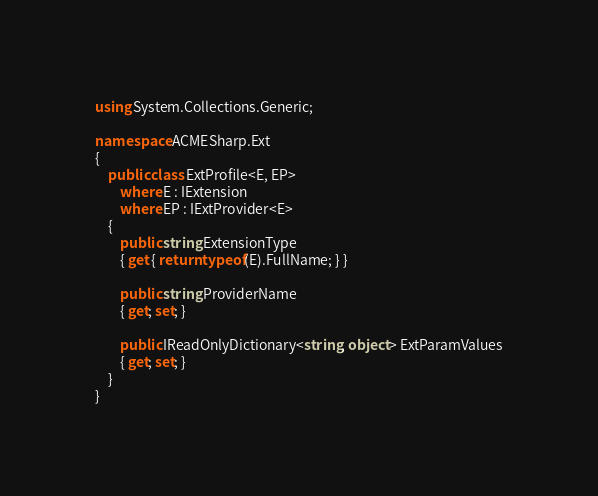<code> <loc_0><loc_0><loc_500><loc_500><_C#_>using System.Collections.Generic;

namespace ACMESharp.Ext
{
    public class ExtProfile<E, EP>
        where E : IExtension
        where EP : IExtProvider<E>
    {
        public string ExtensionType
        { get { return typeof(E).FullName; } }

        public string ProviderName
        { get; set; }

        public IReadOnlyDictionary<string, object> ExtParamValues
        { get; set; }
    }
}</code> 